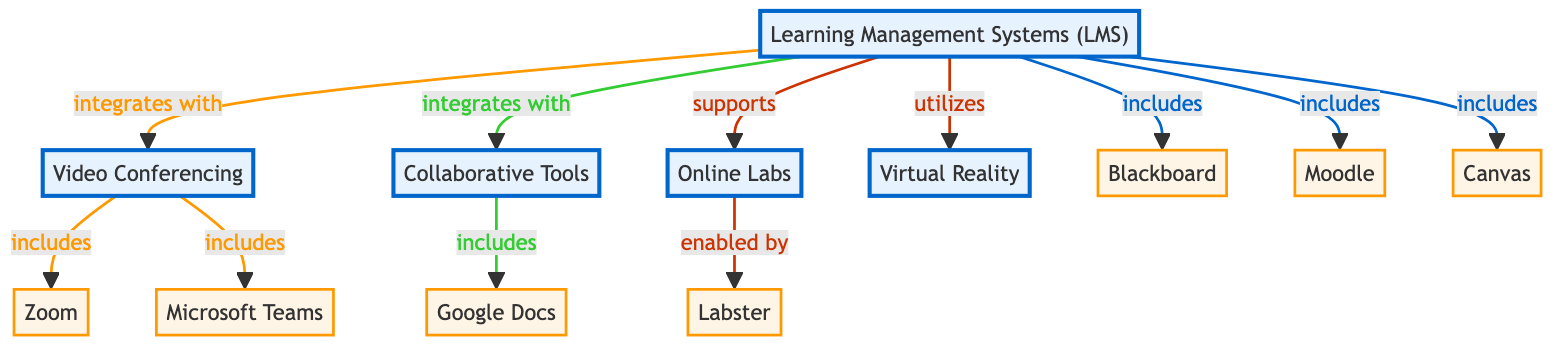What is the central node of the diagram? The central node is "Learning Management Systems (LMS)," as it connects with multiple other nodes and serves as the primary component around which other e-learning technologies are organized.
Answer: Learning Management Systems (LMS) How many nodes are there in total? By counting all unique nodes listed in the data, we find there are 12 nodes in the diagram.
Answer: 12 What type of relationship does "Learning Management Systems (LMS)" have with "Collaborative Tools"? The relationship is "integrates with," as indicated by the directed edge connecting these two nodes labelled as such.
Answer: integrates with Which platform is a sub-node of "Video Conferencing"? "Zoom" and "Microsoft Teams" are both sub-nodes under "Video Conferencing," indicated by the direct edges stemming from the "Video Conferencing" node to these platforms.
Answer: Zoom, Microsoft Teams What does "Online Labs" enable? "Labster" is enabled by "Online Labs," as indicated by the directed edge from "Online Labs" to "Labster."
Answer: Labster Which three LMS platforms are included under "Learning Management Systems"? The three LMS platforms included are "Blackboard," "Moodle," and "Canvas," shown in separate directed edges connecting them to the "Learning Management Systems" node.
Answer: Blackboard, Moodle, Canvas Which technology is highlighted as utilizing "Learning Management Systems"? "Virtual Reality" is highlighted as utilizing "Learning Management Systems," indicated by a directed edge from "Learning Management Systems" to "Virtual Reality."
Answer: Virtual Reality How many integrations does "Learning Management Systems" have? "Learning Management Systems" integrates with three technologies: "Video Conferencing," "Collaborative Tools," and "Online Labs," as represented by the respective edges in the diagram.
Answer: 3 What relationship do both "Zoom" and "Microsoft Teams" have with "Video Conferencing"? Both "Zoom" and "Microsoft Teams" are included in the "Video Conferencing" category, as indicated by directed edges from "Video Conferencing" to these platforms.
Answer: includes Which collaborative tool is part of "Collaborative Tools"? "Google Docs" is part of "Collaborative Tools," shown by the directed edge from "Collaborative Tools" to "Google Docs."
Answer: Google Docs 